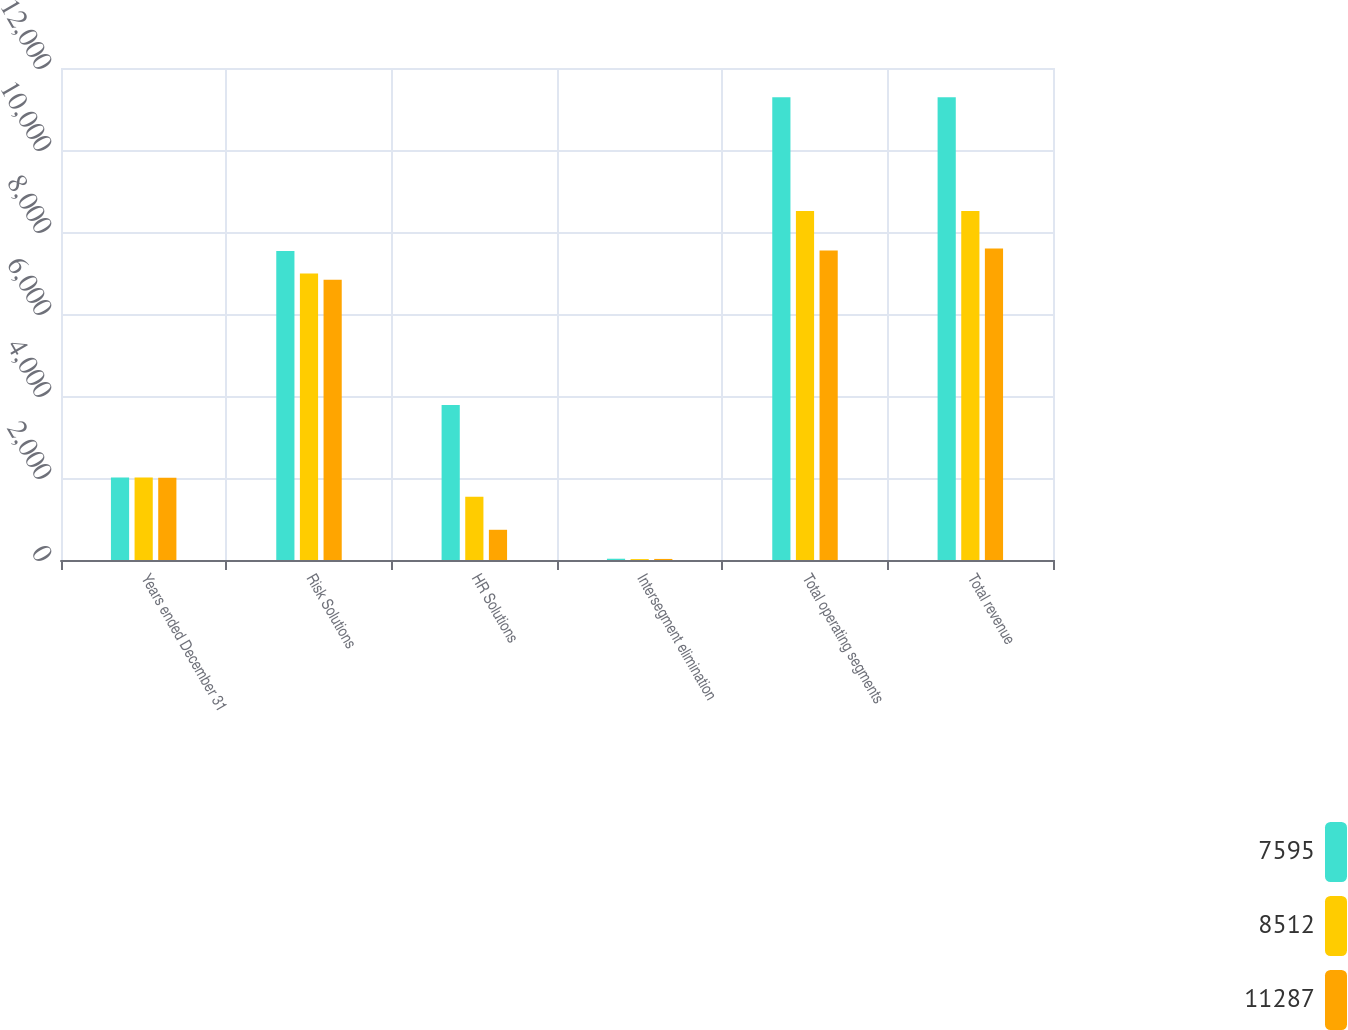Convert chart to OTSL. <chart><loc_0><loc_0><loc_500><loc_500><stacked_bar_chart><ecel><fcel>Years ended December 31<fcel>Risk Solutions<fcel>HR Solutions<fcel>Intersegment elimination<fcel>Total operating segments<fcel>Total revenue<nl><fcel>7595<fcel>2011<fcel>7537<fcel>3781<fcel>31<fcel>11287<fcel>11287<nl><fcel>8512<fcel>2010<fcel>6989<fcel>1545<fcel>22<fcel>8512<fcel>8512<nl><fcel>11287<fcel>2009<fcel>6835<fcel>737<fcel>26<fcel>7546<fcel>7595<nl></chart> 